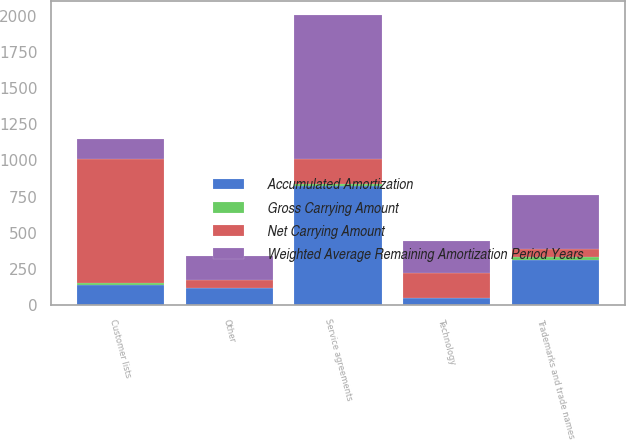Convert chart. <chart><loc_0><loc_0><loc_500><loc_500><stacked_bar_chart><ecel><fcel>Customer lists<fcel>Service agreements<fcel>Trademarks and trade names<fcel>Technology<fcel>Other<nl><fcel>Gross Carrying Amount<fcel>10<fcel>16<fcel>15<fcel>3<fcel>5<nl><fcel>Weighted Average Remaining Amortization Period Years<fcel>139<fcel>995<fcel>371<fcel>219<fcel>165<nl><fcel>Net Carrying Amount<fcel>863<fcel>173<fcel>59<fcel>173<fcel>52<nl><fcel>Accumulated Amortization<fcel>139<fcel>822<fcel>312<fcel>46<fcel>113<nl></chart> 